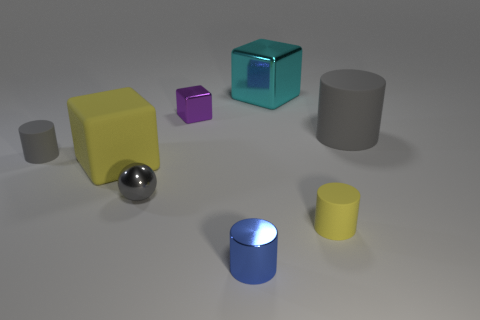Add 1 yellow cylinders. How many objects exist? 9 Add 5 small purple objects. How many small purple objects are left? 6 Add 2 gray matte objects. How many gray matte objects exist? 4 Subtract all gray cylinders. How many cylinders are left? 2 Subtract all small blue metallic cylinders. How many cylinders are left? 3 Subtract 1 blue cylinders. How many objects are left? 7 Subtract all spheres. How many objects are left? 7 Subtract 1 cylinders. How many cylinders are left? 3 Subtract all cyan balls. Subtract all cyan cylinders. How many balls are left? 1 Subtract all purple cubes. How many gray cylinders are left? 2 